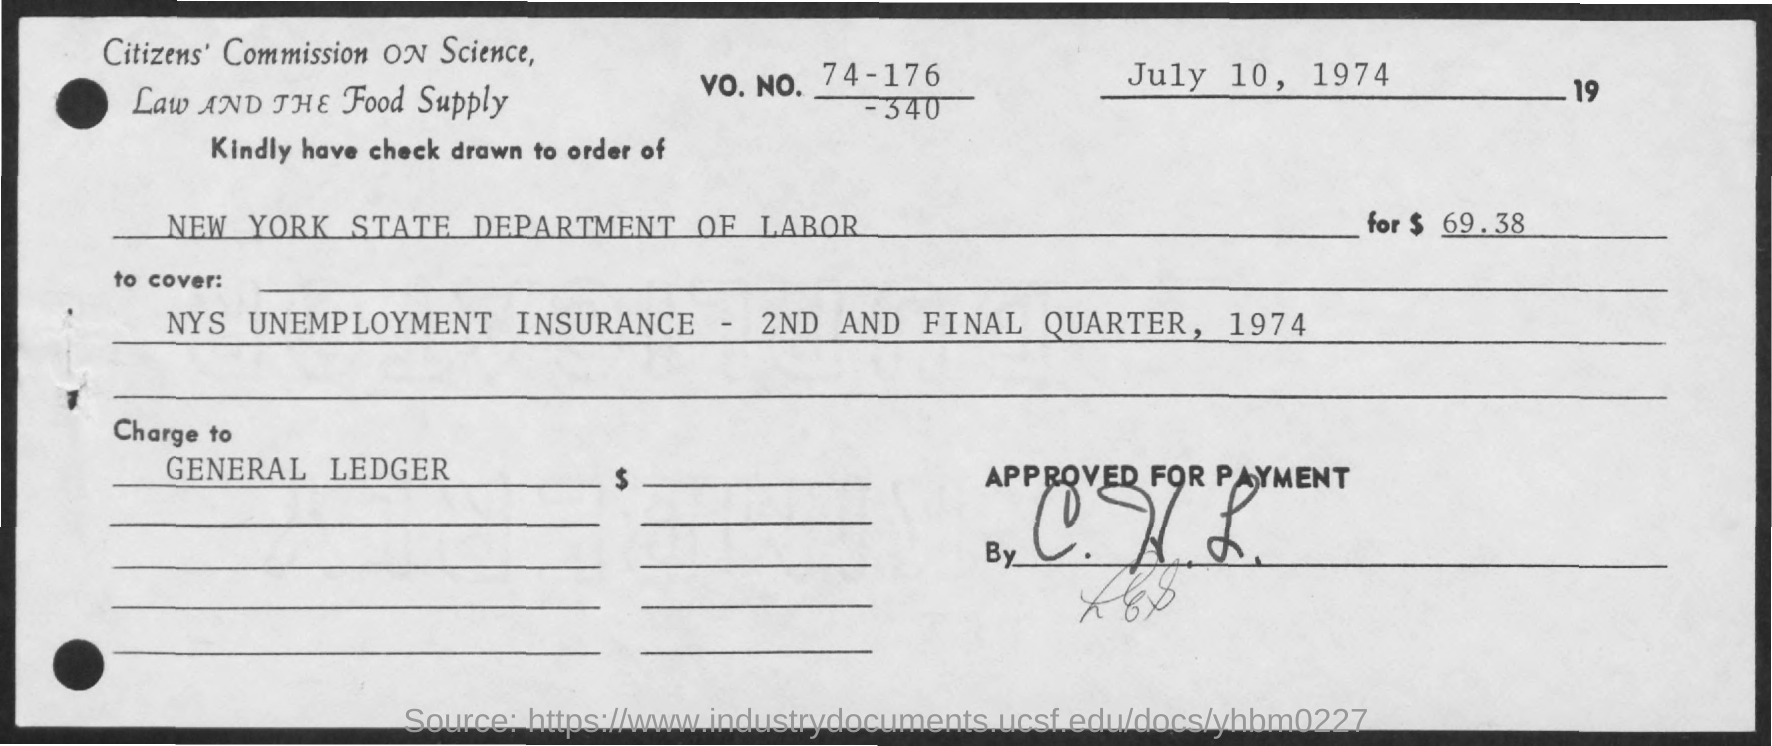Mention a couple of crucial points in this snapshot. The check must be drawn to the New York State Department of Labor. The date mentioned in the given check is July 10, 1974. The VO.NO. mentioned in the given check is 74-176-340... 